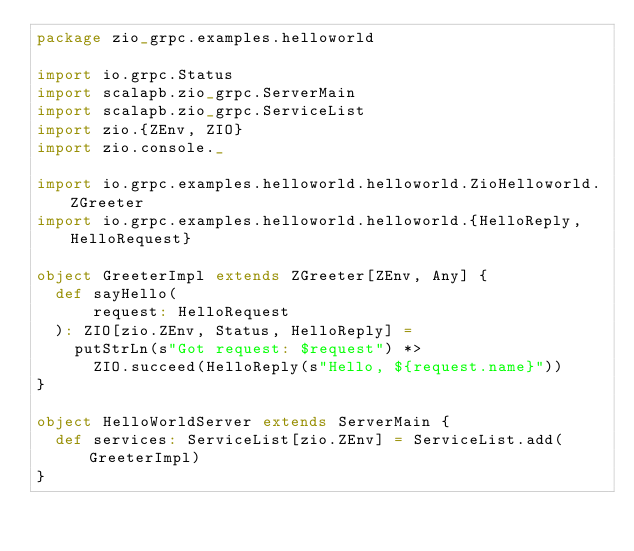<code> <loc_0><loc_0><loc_500><loc_500><_Scala_>package zio_grpc.examples.helloworld

import io.grpc.Status
import scalapb.zio_grpc.ServerMain
import scalapb.zio_grpc.ServiceList
import zio.{ZEnv, ZIO}
import zio.console._

import io.grpc.examples.helloworld.helloworld.ZioHelloworld.ZGreeter
import io.grpc.examples.helloworld.helloworld.{HelloReply, HelloRequest}

object GreeterImpl extends ZGreeter[ZEnv, Any] {
  def sayHello(
      request: HelloRequest
  ): ZIO[zio.ZEnv, Status, HelloReply] =
    putStrLn(s"Got request: $request") *>
      ZIO.succeed(HelloReply(s"Hello, ${request.name}"))
}

object HelloWorldServer extends ServerMain {
  def services: ServiceList[zio.ZEnv] = ServiceList.add(GreeterImpl)
}
</code> 